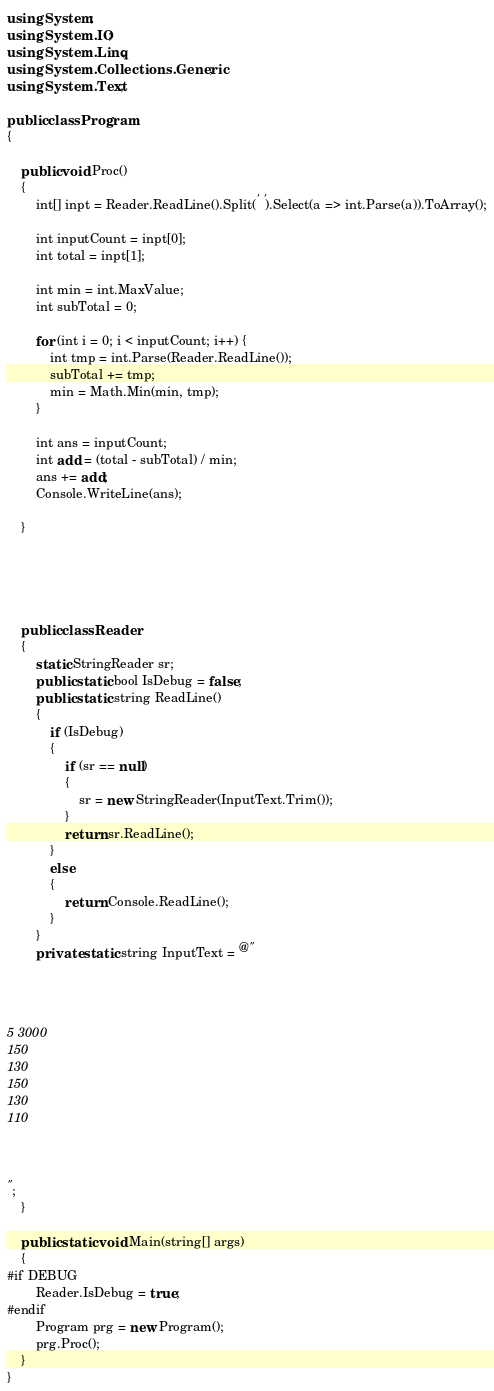<code> <loc_0><loc_0><loc_500><loc_500><_C#_>using System;
using System.IO;
using System.Linq;
using System.Collections.Generic;
using System.Text;

public class Program
{

    public void Proc()
    {
        int[] inpt = Reader.ReadLine().Split(' ').Select(a => int.Parse(a)).ToArray();

        int inputCount = inpt[0];
        int total = inpt[1];

        int min = int.MaxValue;
        int subTotal = 0;

        for (int i = 0; i < inputCount; i++) {
            int tmp = int.Parse(Reader.ReadLine());
            subTotal += tmp;
            min = Math.Min(min, tmp);
        }

        int ans = inputCount;
        int add = (total - subTotal) / min;
        ans += add;
        Console.WriteLine(ans);

    }





    public class Reader
    {
        static StringReader sr;
        public static bool IsDebug = false;
        public static string ReadLine()
        {
            if (IsDebug)
            {
                if (sr == null)
                {
                    sr = new StringReader(InputText.Trim());
                }
                return sr.ReadLine();
            }
            else
            {
                return Console.ReadLine();
            }
        }
        private static string InputText = @"




5 3000
150
130
150
130
110



";
    }

    public static void Main(string[] args)
    {
#if DEBUG
        Reader.IsDebug = true;
#endif
        Program prg = new Program();
        prg.Proc();
    }
}
</code> 